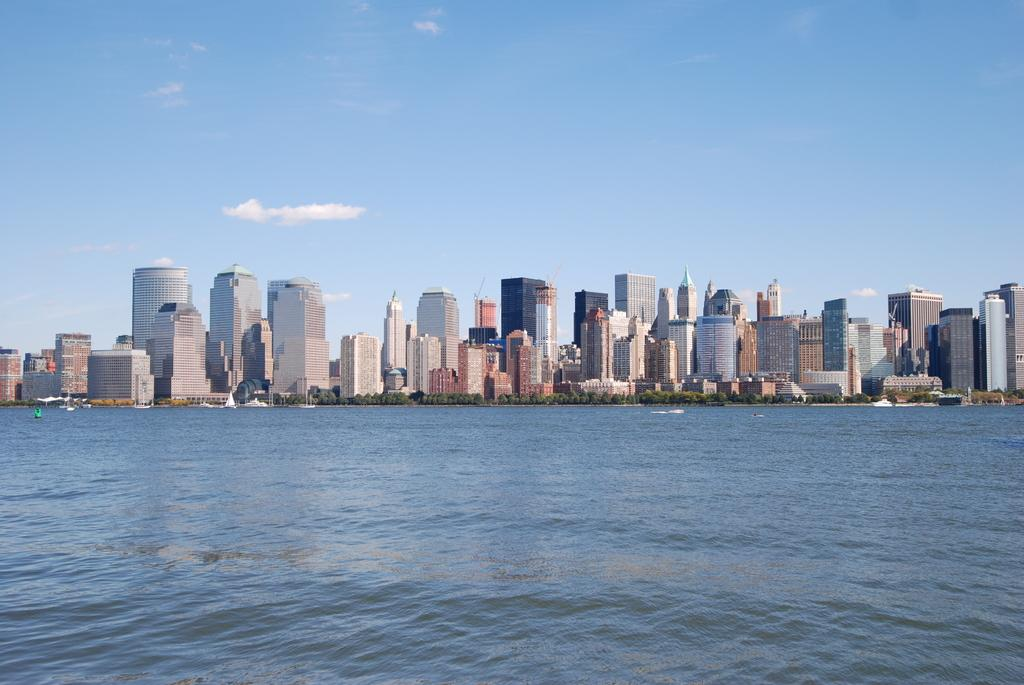What is present at the bottom of the image? There is water at the bottom of the image. What can be seen in the middle of the image? There are trees and buildings in the middle of the image. What is visible at the top of the image? There are clouds and the sky visible at the top of the image. What type of lace can be seen hanging from the trees in the image? There is no lace present in the image; it features water, trees, buildings, clouds, and the sky. What attraction is visible in the image? The image does not depict a specific attraction; it shows a natural landscape with water, trees, buildings, clouds, and the sky. 